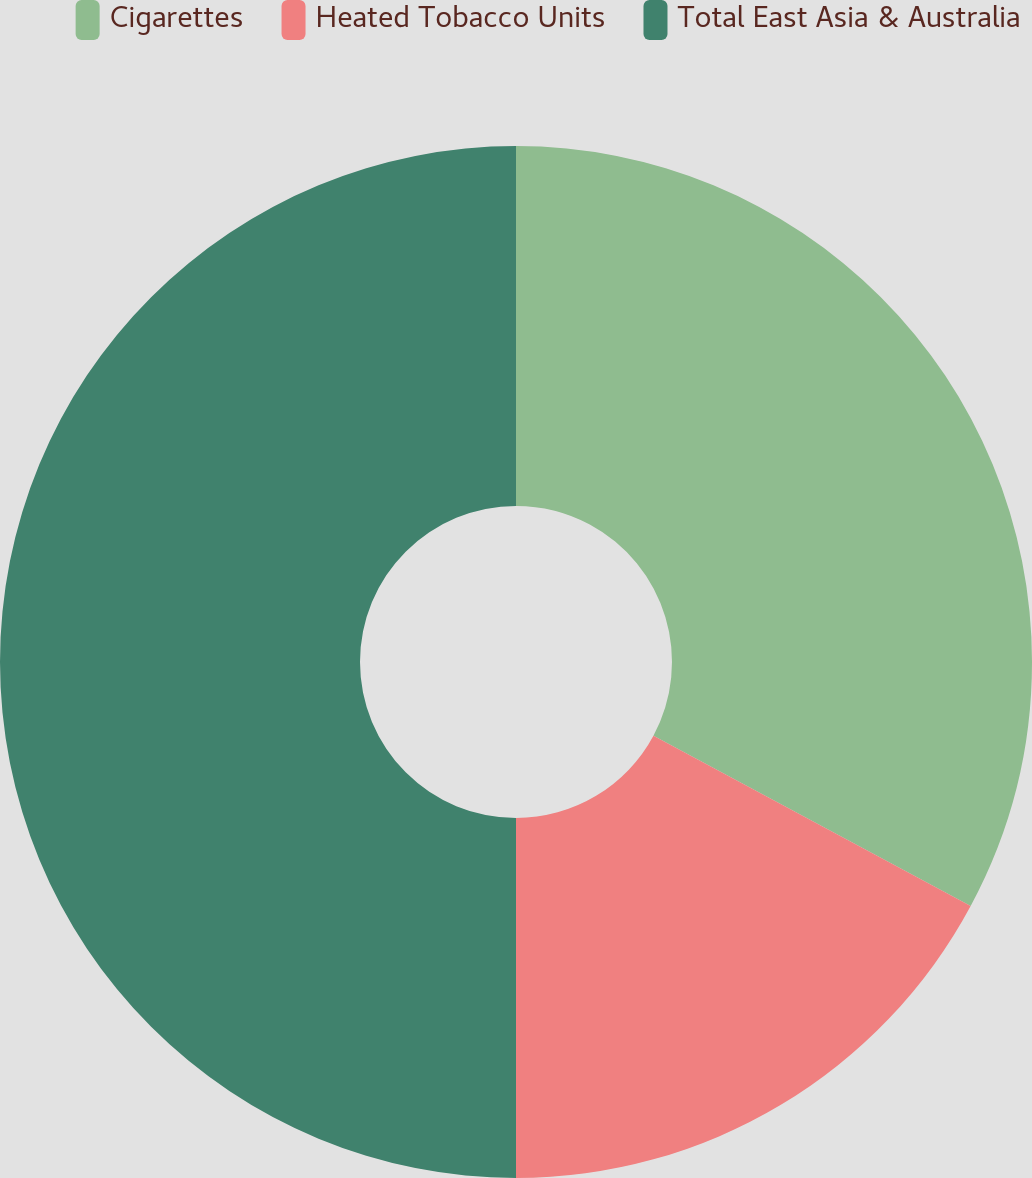<chart> <loc_0><loc_0><loc_500><loc_500><pie_chart><fcel>Cigarettes<fcel>Heated Tobacco Units<fcel>Total East Asia & Australia<nl><fcel>32.84%<fcel>17.16%<fcel>50.0%<nl></chart> 